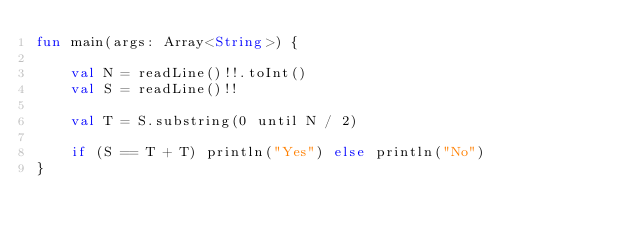<code> <loc_0><loc_0><loc_500><loc_500><_Kotlin_>fun main(args: Array<String>) {

    val N = readLine()!!.toInt()
    val S = readLine()!!

    val T = S.substring(0 until N / 2)

    if (S == T + T) println("Yes") else println("No")
}</code> 